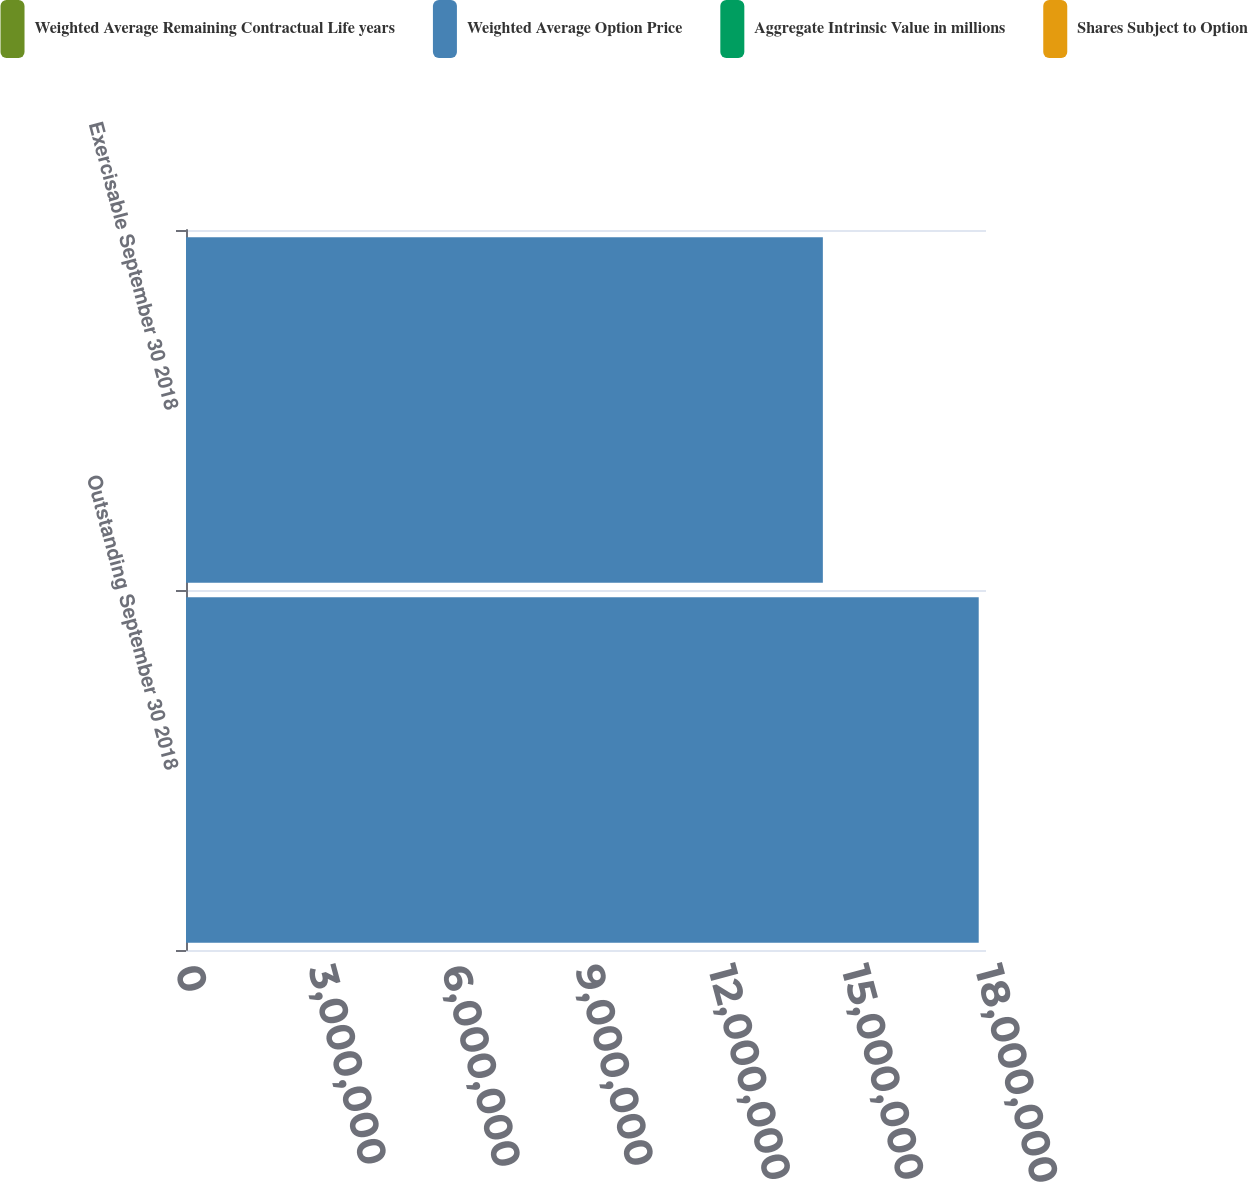Convert chart. <chart><loc_0><loc_0><loc_500><loc_500><stacked_bar_chart><ecel><fcel>Outstanding September 30 2018<fcel>Exercisable September 30 2018<nl><fcel>Weighted Average Remaining Contractual Life years<fcel>34.24<fcel>31.22<nl><fcel>Weighted Average Option Price<fcel>1.78361e+07<fcel>1.43292e+07<nl><fcel>Aggregate Intrinsic Value in millions<fcel>4.2<fcel>3.3<nl><fcel>Shares Subject to Option<fcel>84<fcel>84<nl></chart> 